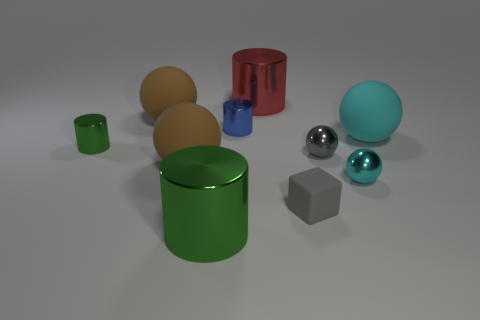Subtract all tiny blue shiny cylinders. How many cylinders are left? 3 Subtract all green cylinders. How many were subtracted if there are1green cylinders left? 1 Subtract 1 cubes. How many cubes are left? 0 Subtract all red cubes. Subtract all yellow balls. How many cubes are left? 1 Subtract all brown cylinders. How many brown balls are left? 2 Subtract all big green metal objects. Subtract all blue cylinders. How many objects are left? 8 Add 1 gray matte cubes. How many gray matte cubes are left? 2 Add 10 large yellow rubber cylinders. How many large yellow rubber cylinders exist? 10 Subtract all green cylinders. How many cylinders are left? 2 Subtract 0 purple cylinders. How many objects are left? 10 